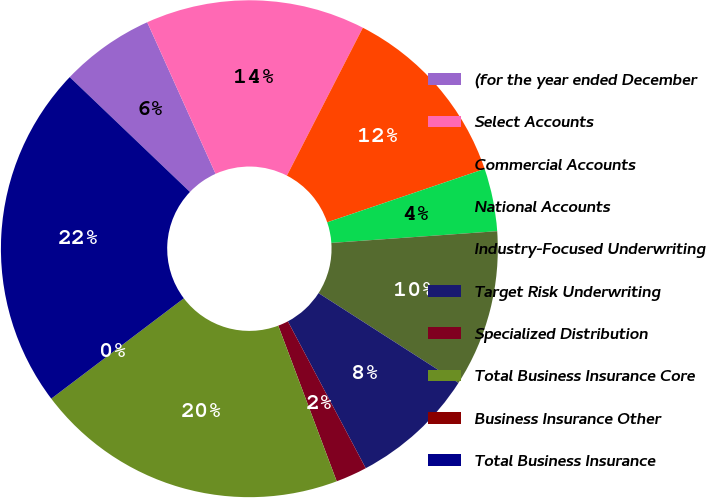Convert chart. <chart><loc_0><loc_0><loc_500><loc_500><pie_chart><fcel>(for the year ended December<fcel>Select Accounts<fcel>Commercial Accounts<fcel>National Accounts<fcel>Industry-Focused Underwriting<fcel>Target Risk Underwriting<fcel>Specialized Distribution<fcel>Total Business Insurance Core<fcel>Business Insurance Other<fcel>Total Business Insurance<nl><fcel>6.12%<fcel>14.29%<fcel>12.24%<fcel>4.08%<fcel>10.2%<fcel>8.16%<fcel>2.04%<fcel>20.4%<fcel>0.0%<fcel>22.44%<nl></chart> 